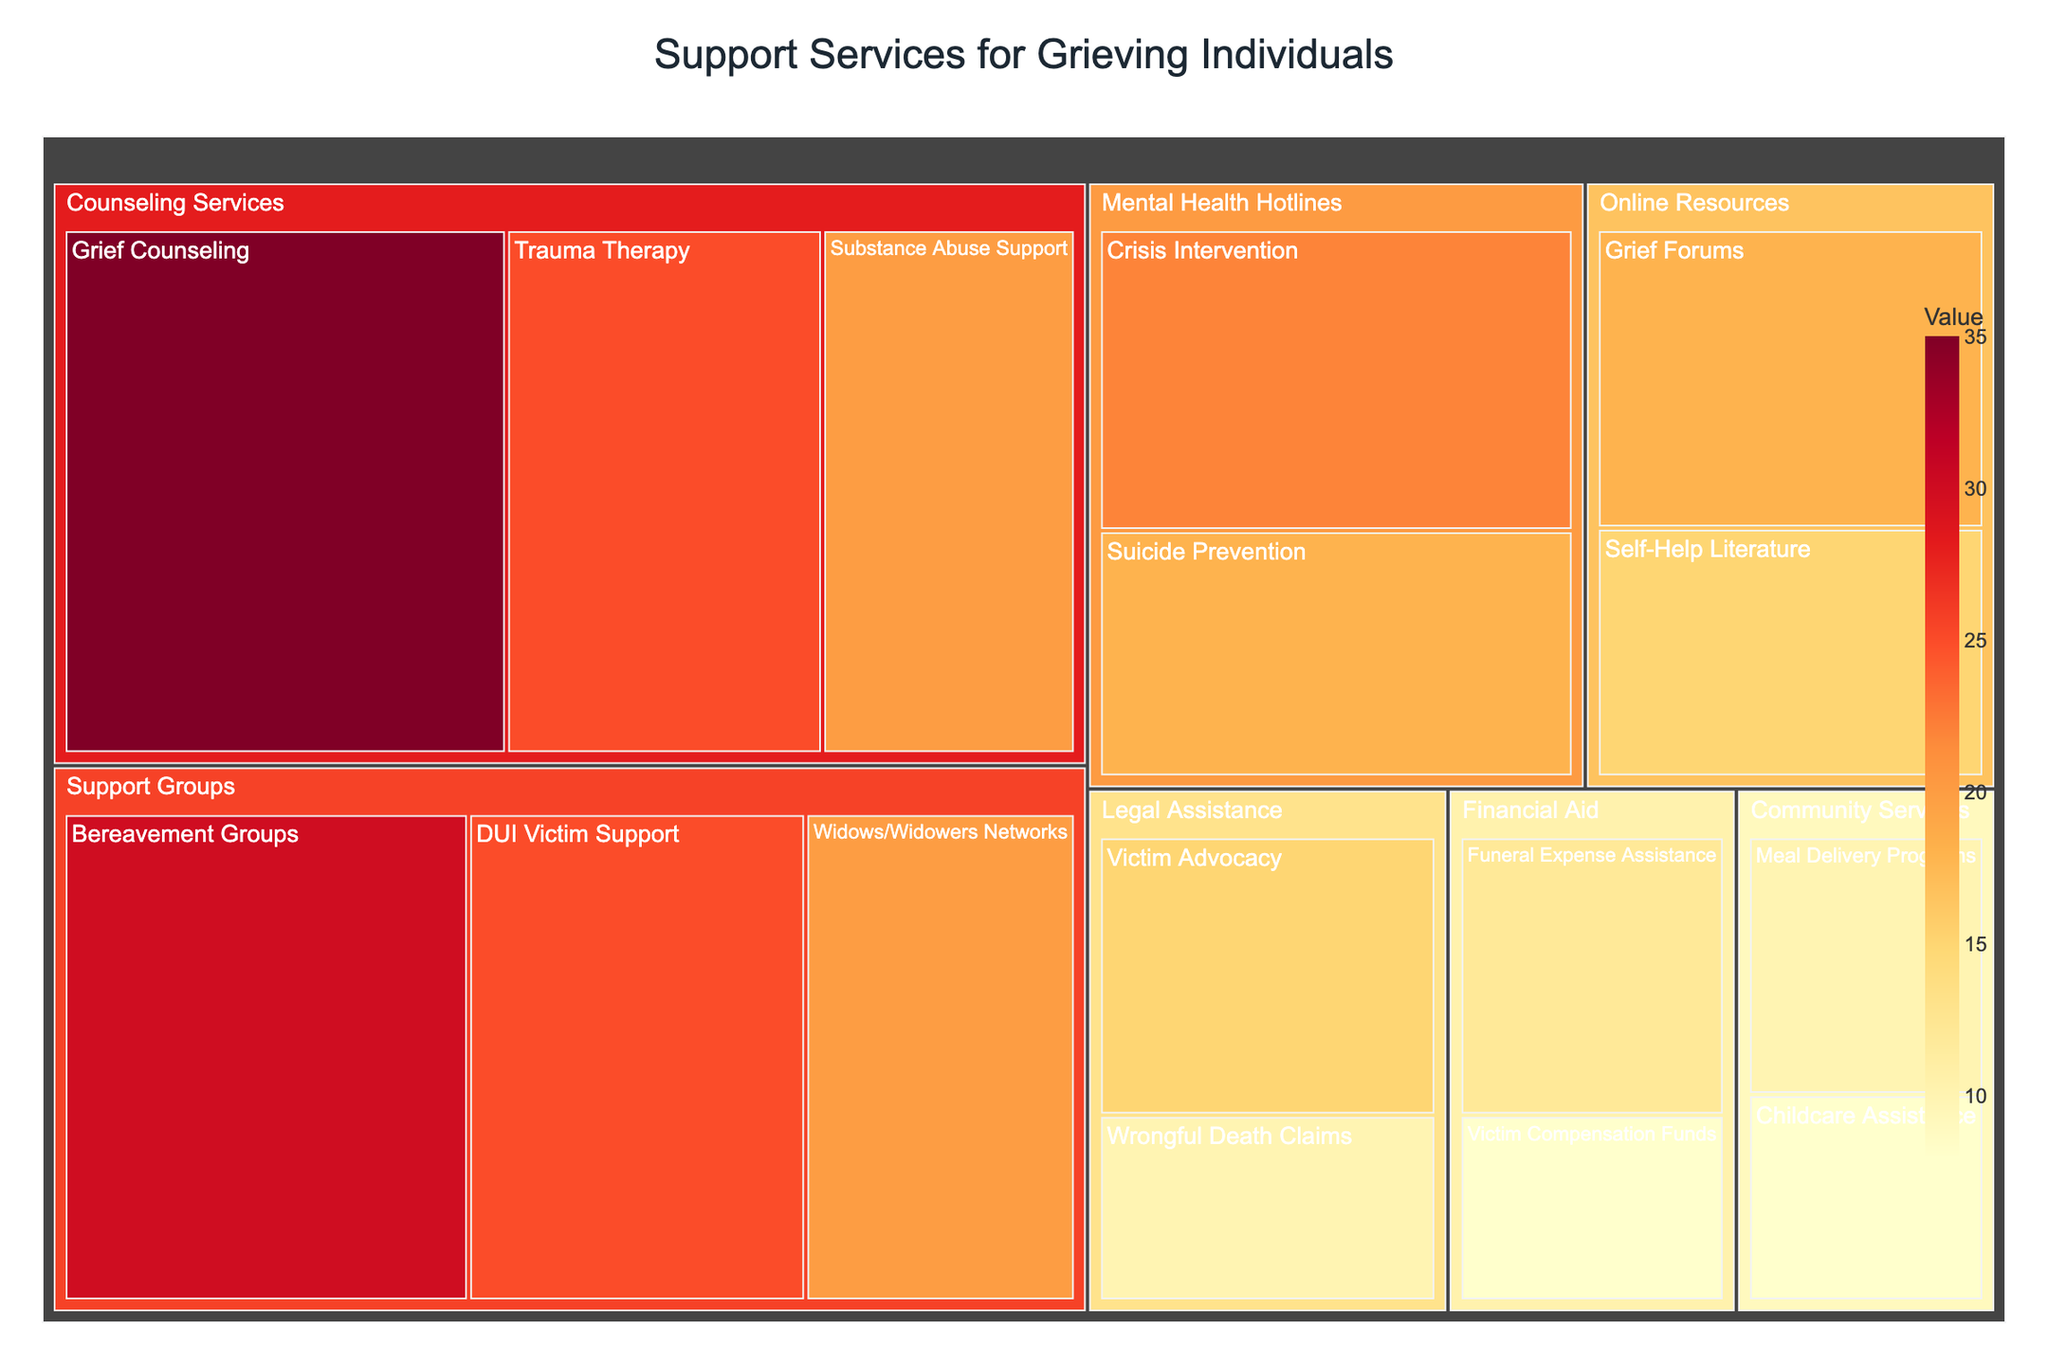what is the title of the Treemap? The title is usually displayed at the top of the Treemap, typically centered and in a larger font size. Look in this location to find it.
Answer: Support Services for Grieving Individuals Which category has the highest total value? Scan the treemap and sum up the values for each main category. The category with the highest total value is the one with the sum of all its subcategory values greater than any other category. Counseling Services has 35 + 25 + 20 = 80, Support Groups has 30 + 25 + 20 = 75, Legal Assistance has 15 + 10 = 25, Financial Aid has 12 + 8 = 20, Online Resources has 18 + 15 = 33, Community Services has 10 + 8 = 18, Mental Health Hotlines has 22 + 18 = 40. Therefore, Counseling Services has the highest total value.
Answer: Counseling Services Which subcategory within Support Groups has the lowest value? Scan within the Support Groups category and compare the values of the subcategories. Bereavement Groups have 30, DUI Victim Support has 25, and Widows/Widowers Networks have 20. The lowest value is thus in the Widows/Widowers Networks subcategory.
Answer: Widows/Widowers Networks What is the difference in value between Crisis Intervention and Suicide Prevention in the Mental Health Hotlines category? Find the value for Crisis Intervention (22) and for Suicide Prevention (18) in the Mental Health Hotlines category. Subtract the smaller value from the larger value: 22 - 18 = 4.
Answer: 4 Which subcategory has the highest value within the Counseling Services category? Look at the values listed under each subcategory in Counseling Services. Grief Counseling has 35, Trauma Therapy has 25, and Substance Abuse Support has 20. The highest value is thus Grief Counseling.
Answer: Grief Counseling What is the combined value of Legal Assistance and Financial Aid categories? Add up all values of the subcategories within Legal Assistance and Financial Aid. Legal Assistance has Victim Advocacy (15) + Wrongful Death Claims (10) = 25. Financial Aid has Funeral Expense Assistance (12) + Victim Compensation Funds (8) = 20. Their combined value is 25 + 20 = 45.
Answer: 45 Which category has a higher total value: Online Resources or Community Services? Sum the subcategory values for Online Resources and Community Services. Online Resources has Grief Forums (18) + Self-Help Literature (15) = 33. Community Services has Meal Delivery Programs (10) + Childcare Assistance (8) = 18. Therefore, Online Resources has a higher total value.
Answer: Online Resources What is the proportion of Grief Counseling within the Counseling Services category? Take the value of Grief Counseling (35) and divide it by the total value of Counseling Services (80). Then multiply by 100 to get the percentage: (35 / 80) * 100 = 43.75%.
Answer: 43.75% Which support service provides the most assistance for victims of drunk driving incidents? Look for subcategories that are related to drunk driving within the treemap. DUI Victim Support under Support Groups has a value of 25, which is the highest amongst relevant categories.
Answer: DUI Victim Support What is the total number of subcategories present in the Treemap? Count all the individual subcategories listed under each main category: Counseling Services (3), Support Groups (3), Legal Assistance (2), Financial Aid (2), Online Resources (2), Community Services (2), Mental Health Hotlines (2). Sum all these values: 3 + 3 + 2 + 2 + 2 + 2 + 2 = 16.
Answer: 16 